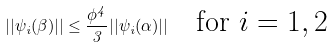<formula> <loc_0><loc_0><loc_500><loc_500>| | \psi _ { i } ( \beta ) | | \leq \frac { \phi ^ { 4 } } { 3 } | | \psi _ { i } ( \alpha ) | | \quad \text {for $i=1,2$}</formula> 